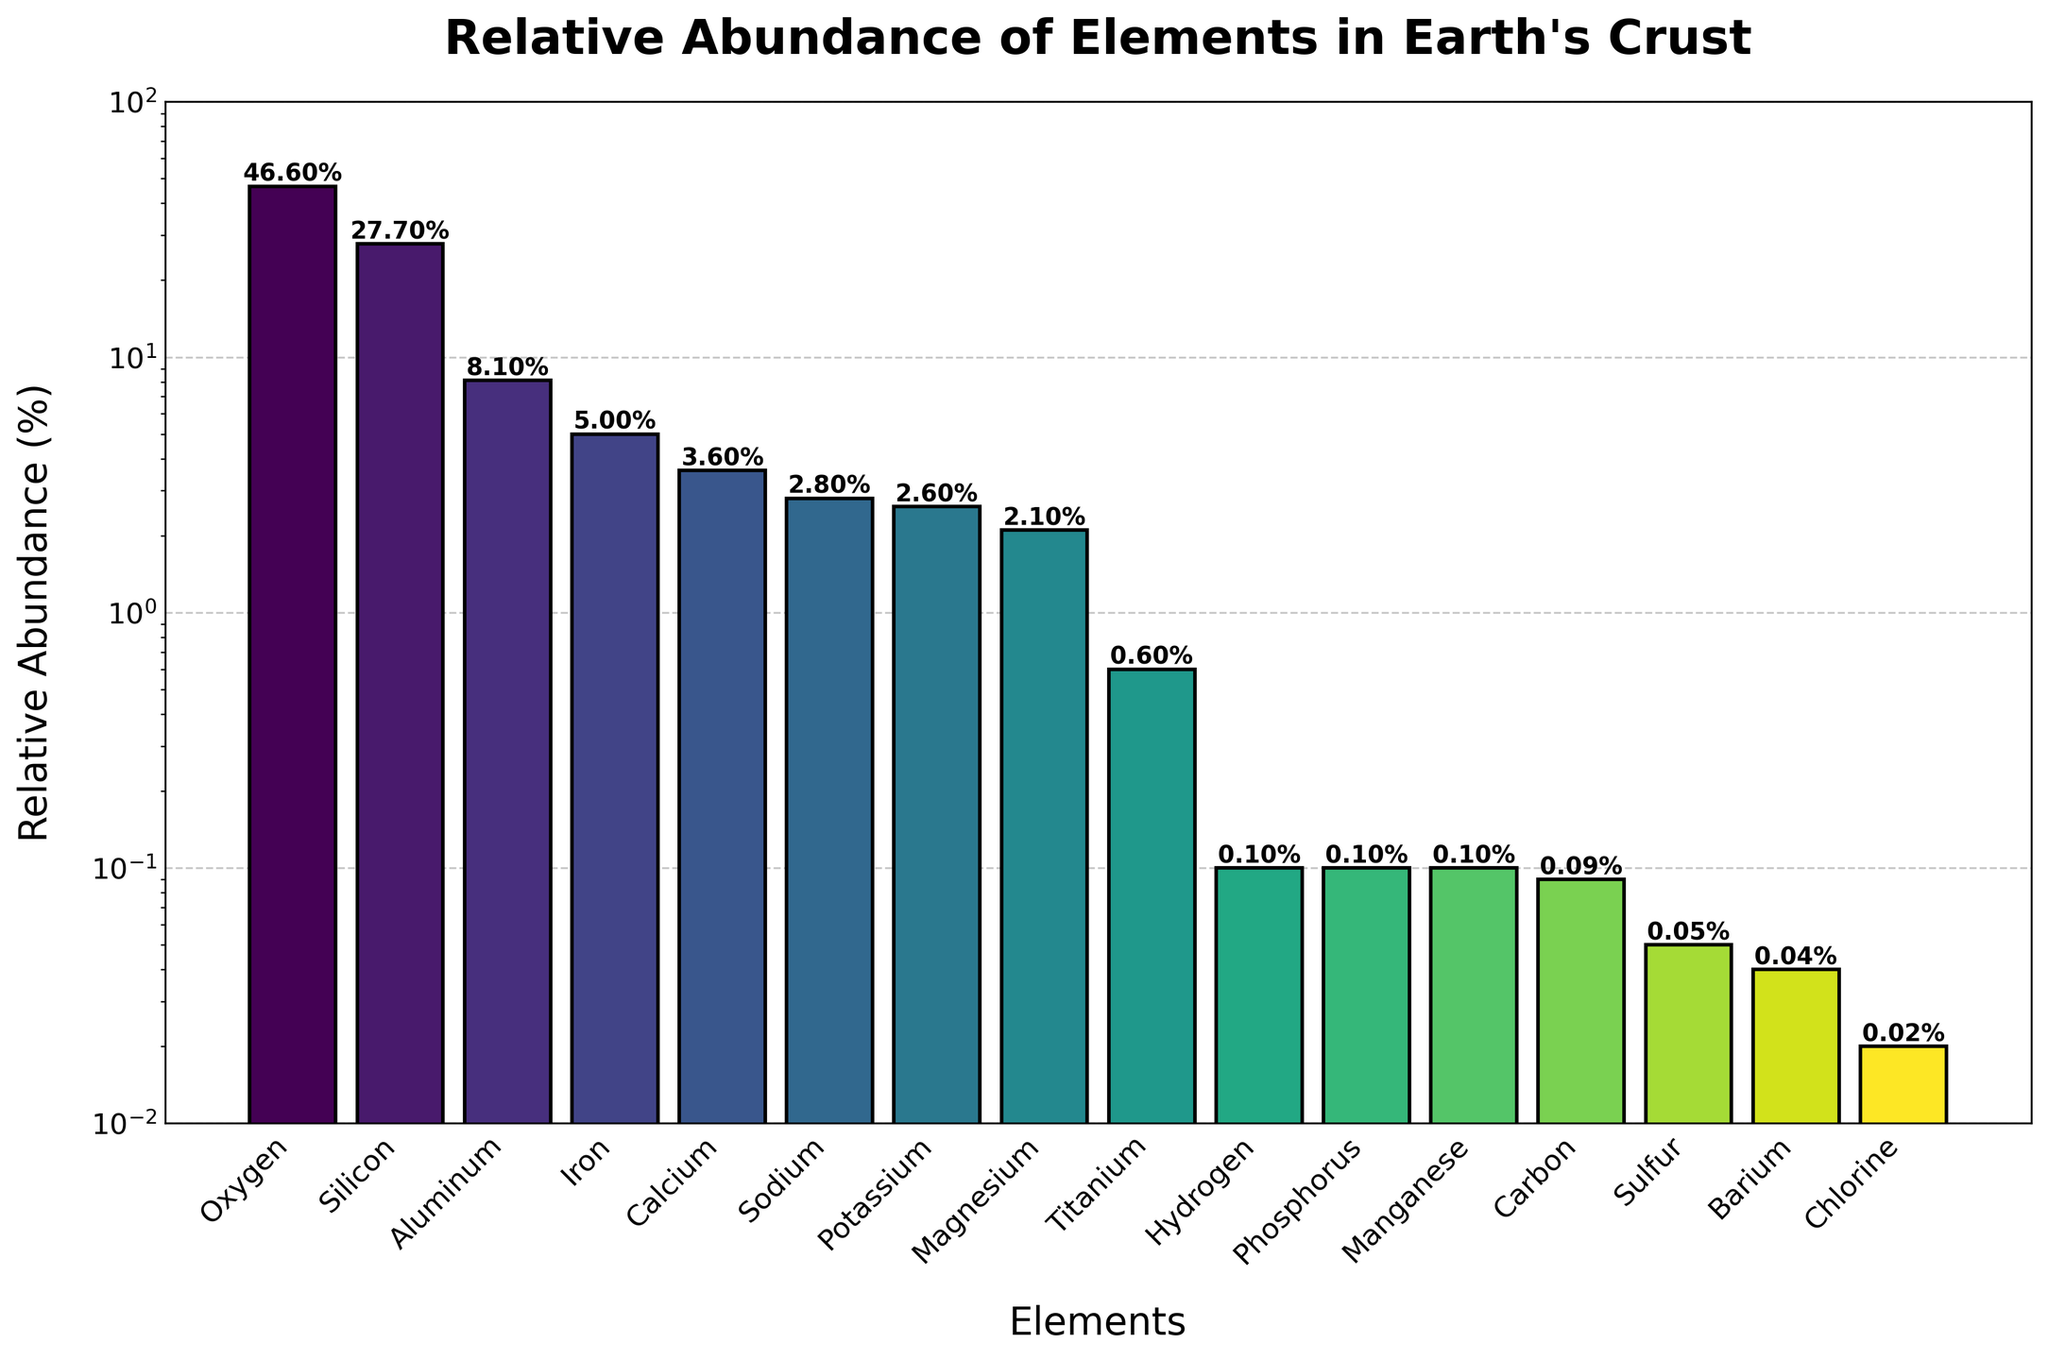What's the most abundant element in the Earth's crust? The bar corresponding to oxygen stands out as the tallest, indicating it has the highest relative abundance. Confirming with the axis labels, oxygen has a relative abundance of 46.6%.
Answer: Oxygen Which element has a relative abundance closest to 5%? By examining the height of the bars around the 5% mark on the y-axis, the bar for iron matches this value. According to the figure, iron's relative abundance is exactly 5.0%.
Answer: Iron How many elements have a relative abundance of less than 1%? Counting the bars that do not reach the 1% threshold on the y-axis, we observe the elements are Titanium, Hydrogen, Phosphorus, Manganese, Carbon, Sulfur, Barium, and Chlorine, which total 8 elements.
Answer: 8 What is the combined relative abundance of the two least abundant elements? The two least abundant elements based on the bar heights are sulfur (0.05%) and chlorine (0.02%). Adding these values together results: 0.05% + 0.02% = 0.07%.
Answer: 0.07% Among aluminum and calcium, which element is more abundant? Comparing the heights of the bars for aluminum and calcium, aluminum's bar is higher. Thus, aluminum has a higher relative abundance (8.1%) compared to calcium (3.6%).
Answer: Aluminum What's the relative abundance difference between silicon and magnesium? The height difference between the bars shows silicon at 27.7% and magnesium at 2.1%. Subtracting magnesium's abundance from silicon's abundance: 27.7% - 2.1% = 25.6%.
Answer: 25.6% Which element is represented by the shortest bar on the chart? The shortest bar on the chart corresponds to chlorine with a relative abundance of 0.02%.
Answer: Chlorine If you consider only the elements with an abundance higher than 2%, what is the average relative abundance of these elements? The elements with more than 2% relative abundance are oxygen (46.6%), silicon (27.7%), aluminum (8.1%), iron (5.0%), calcium (3.6%), sodium (2.8%), potassium (2.6%), and magnesium (2.1%). Summing these values: 46.6 + 27.7 + 8.1 + 5.0 + 3.6 + 2.8 + 2.6 + 2.1 = 98.5%. There are 8 elements, so the average is 98.5% / 8 = 12.31%.
Answer: 12.31% What's the total relative abundance of all the elements whose bars have a value label less than 2%? The elements with less than 2% relative abundance are titanium (0.6%), hydrogen (0.1%), phosphorus (0.1%), manganese (0.1%), carbon (0.09%), sulfur (0.05%), barium (0.04%), chlorine (0.02%). Summing these values: 0.6 + 0.1 + 0.1 + 0.1 + 0.09 + 0.05 + 0.04 + 0.02 = 1.10%.
Answer: 1.10% What is the sum of the relative abundances of the three most abundant elements? The three most abundant elements are oxygen (46.6%), silicon (27.7%), and aluminum (8.1%). Summing these values: 46.6 + 27.7 + 8.1 = 82.4%.
Answer: 82.4% 